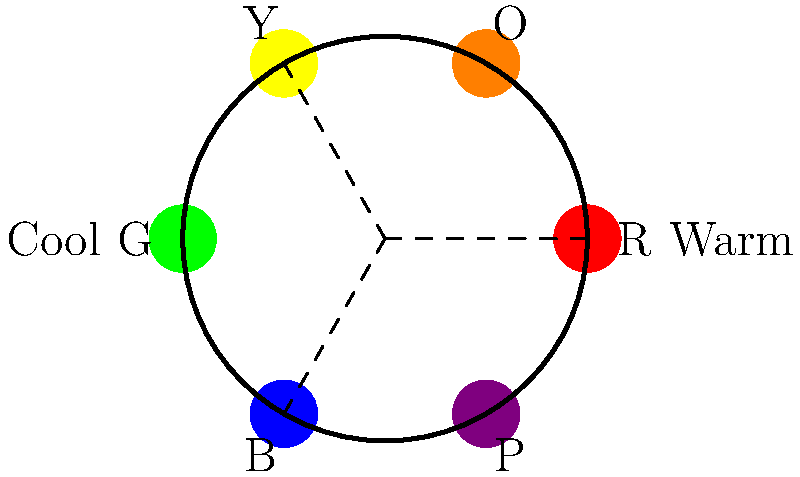In a family drama scene, you want to emphasize the emotional distance between a mother and daughter using color grading. Given the color wheel above, which complementary color pair would you use to visually represent their conflicting perspectives, and how would you apply these colors in the scene? 1. Analyze the color wheel: The wheel shows primary and secondary colors arranged in a circular format.

2. Identify complementary colors: Complementary colors are directly opposite each other on the color wheel. In this case, we see Red (R) is opposite Green (G), Blue (B) is opposite Orange (O), and Purple (P) is opposite Yellow (Y).

3. Choose a suitable pair: For a mother-daughter conflict, we can use Blue and Orange. Blue often represents calmness, stability, and tradition, while Orange symbolizes warmth, energy, and change.

4. Apply colors to the scene:
   a) Use cooler blue tones in the mother's environment or clothing to represent her more traditional, stable perspective.
   b) Apply warmer orange tones to the daughter's surroundings or attire to show her desire for change or her more energetic, rebellious nature.

5. Implement the color grading:
   a) In shots focusing on the mother, subtly increase blue tones in shadows and midtones.
   b) For the daughter's scenes, enhance orange hues in highlights and midtones.
   c) In shared scenes, create visual tension by having these colors interact or clash.

6. Consider lighting: Use cooler light sources (e.g., moonlight, cool indoor lighting) for the mother's scenes and warmer light sources (e.g., sunset, warm indoor lighting) for the daughter's scenes.

7. Balance the effect: Ensure the color grading is noticeable but not overpowering, maintaining a natural look while subtly influencing the viewer's perception of the characters' emotional states and relationship.
Answer: Blue for mother (tradition/stability) and Orange for daughter (change/energy), applied through color grading of environments, costumes, and lighting. 